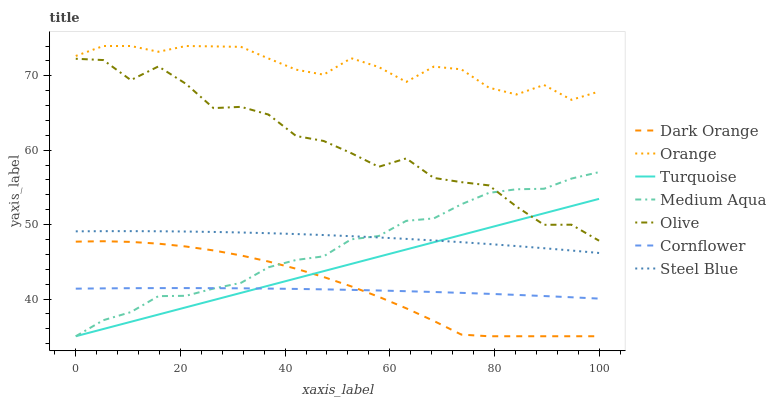Does Cornflower have the minimum area under the curve?
Answer yes or no. Yes. Does Orange have the maximum area under the curve?
Answer yes or no. Yes. Does Turquoise have the minimum area under the curve?
Answer yes or no. No. Does Turquoise have the maximum area under the curve?
Answer yes or no. No. Is Turquoise the smoothest?
Answer yes or no. Yes. Is Olive the roughest?
Answer yes or no. Yes. Is Cornflower the smoothest?
Answer yes or no. No. Is Cornflower the roughest?
Answer yes or no. No. Does Dark Orange have the lowest value?
Answer yes or no. Yes. Does Cornflower have the lowest value?
Answer yes or no. No. Does Orange have the highest value?
Answer yes or no. Yes. Does Turquoise have the highest value?
Answer yes or no. No. Is Olive less than Orange?
Answer yes or no. Yes. Is Olive greater than Steel Blue?
Answer yes or no. Yes. Does Dark Orange intersect Cornflower?
Answer yes or no. Yes. Is Dark Orange less than Cornflower?
Answer yes or no. No. Is Dark Orange greater than Cornflower?
Answer yes or no. No. Does Olive intersect Orange?
Answer yes or no. No. 